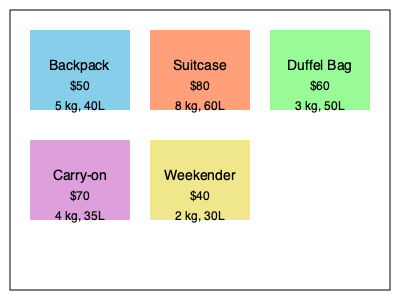Based on the luggage options shown, which one offers the best combination of affordability, capacity, and lightweight design for a budget traveler who needs sufficient space for a week-long trip? Let's analyze each option step-by-step:

1. Backpack: $50, 5 kg, 40L
   - Moderately priced
   - Good capacity
   - Relatively lightweight

2. Suitcase: $80, 8 kg, 60L
   - Most expensive option
   - Highest capacity
   - Heaviest option

3. Duffel Bag: $60, 3 kg, 50L
   - Moderately priced
   - Second-highest capacity
   - Very lightweight

4. Carry-on: $70, 4 kg, 35L
   - Second most expensive option
   - Limited capacity
   - Relatively lightweight

5. Weekender: $40, 2 kg, 30L
   - Cheapest option
   - Smallest capacity
   - Lightest option

For a week-long trip, we need sufficient capacity (at least 40L) while considering weight and price. The duffel bag offers the best combination:
- It has the second-highest capacity (50L), which is suitable for a week-long trip.
- It's the second lightest option at 3 kg, making it easy to carry.
- The price ($60) is in the middle range, offering good value for its features.

While the backpack is slightly cheaper, the duffel bag offers more capacity and is lighter. The suitcase has more capacity but is significantly heavier and more expensive. The carry-on and weekender don't offer enough capacity for a week-long trip.
Answer: Duffel Bag 